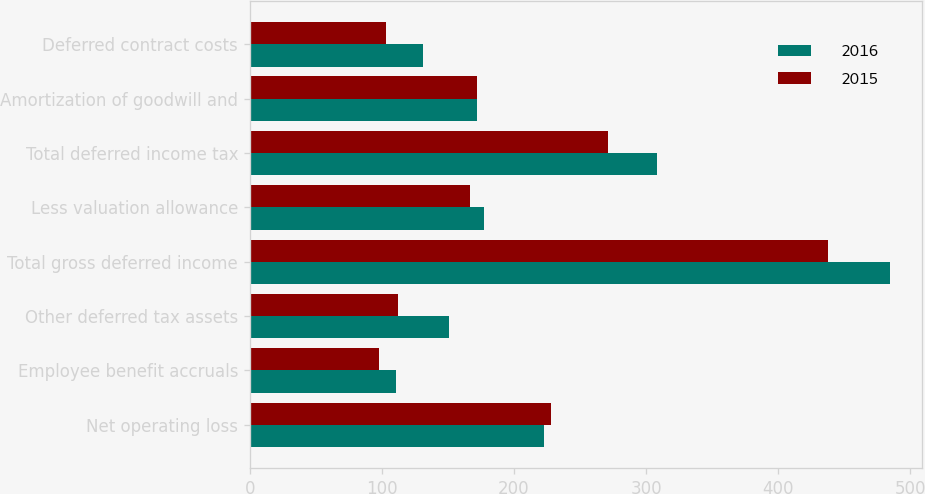Convert chart to OTSL. <chart><loc_0><loc_0><loc_500><loc_500><stacked_bar_chart><ecel><fcel>Net operating loss<fcel>Employee benefit accruals<fcel>Other deferred tax assets<fcel>Total gross deferred income<fcel>Less valuation allowance<fcel>Total deferred income tax<fcel>Amortization of goodwill and<fcel>Deferred contract costs<nl><fcel>2016<fcel>223<fcel>111<fcel>151<fcel>485<fcel>177<fcel>308<fcel>172<fcel>131<nl><fcel>2015<fcel>228<fcel>98<fcel>112<fcel>438<fcel>167<fcel>271<fcel>172<fcel>103<nl></chart> 